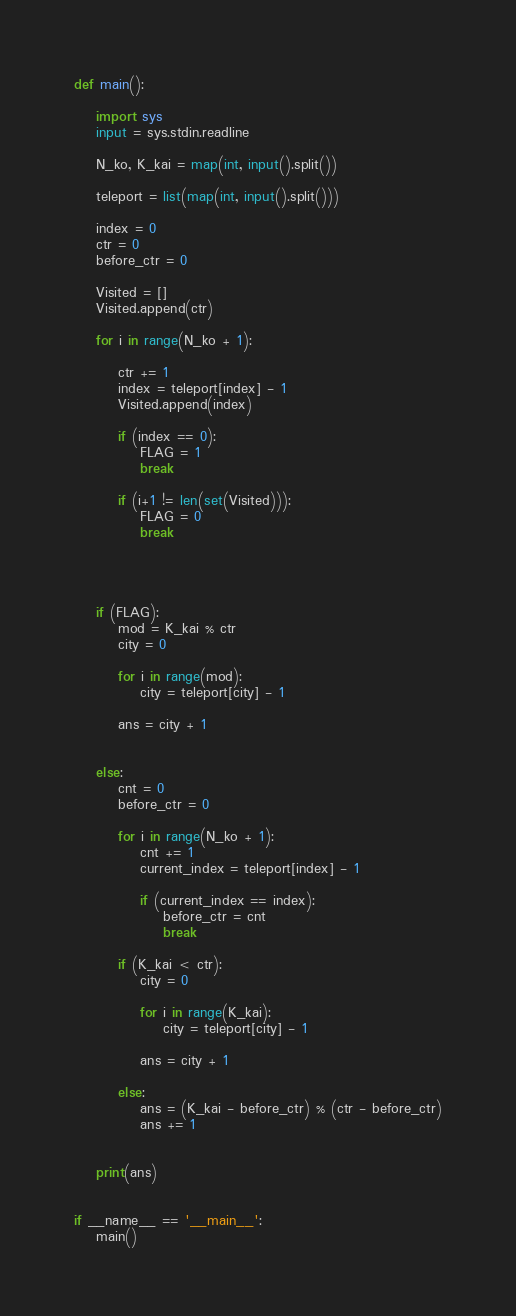<code> <loc_0><loc_0><loc_500><loc_500><_Cython_>def main():

    import sys
    input = sys.stdin.readline

    N_ko, K_kai = map(int, input().split())
    
    teleport = list(map(int, input().split()))

    index = 0
    ctr = 0
    before_ctr = 0

    Visited = []
    Visited.append(ctr)

    for i in range(N_ko + 1):

        ctr += 1
        index = teleport[index] - 1
        Visited.append(index)
        
        if (index == 0):
            FLAG = 1
            break

        if (i+1 != len(set(Visited))):
            FLAG = 0
            break
    
    


    if (FLAG):
        mod = K_kai % ctr
        city = 0

        for i in range(mod):
            city = teleport[city] - 1

        ans = city + 1


    else:
        cnt = 0
        before_ctr = 0

        for i in range(N_ko + 1):
            cnt += 1
            current_index = teleport[index] - 1
            
            if (current_index == index):
                before_ctr = cnt
                break
        
        if (K_kai < ctr):
            city = 0
            
            for i in range(K_kai):
                city = teleport[city] - 1

            ans = city + 1

        else:
            ans = (K_kai - before_ctr) % (ctr - before_ctr)
            ans += 1
            

    print(ans)


if __name__ == '__main__':
    main()</code> 